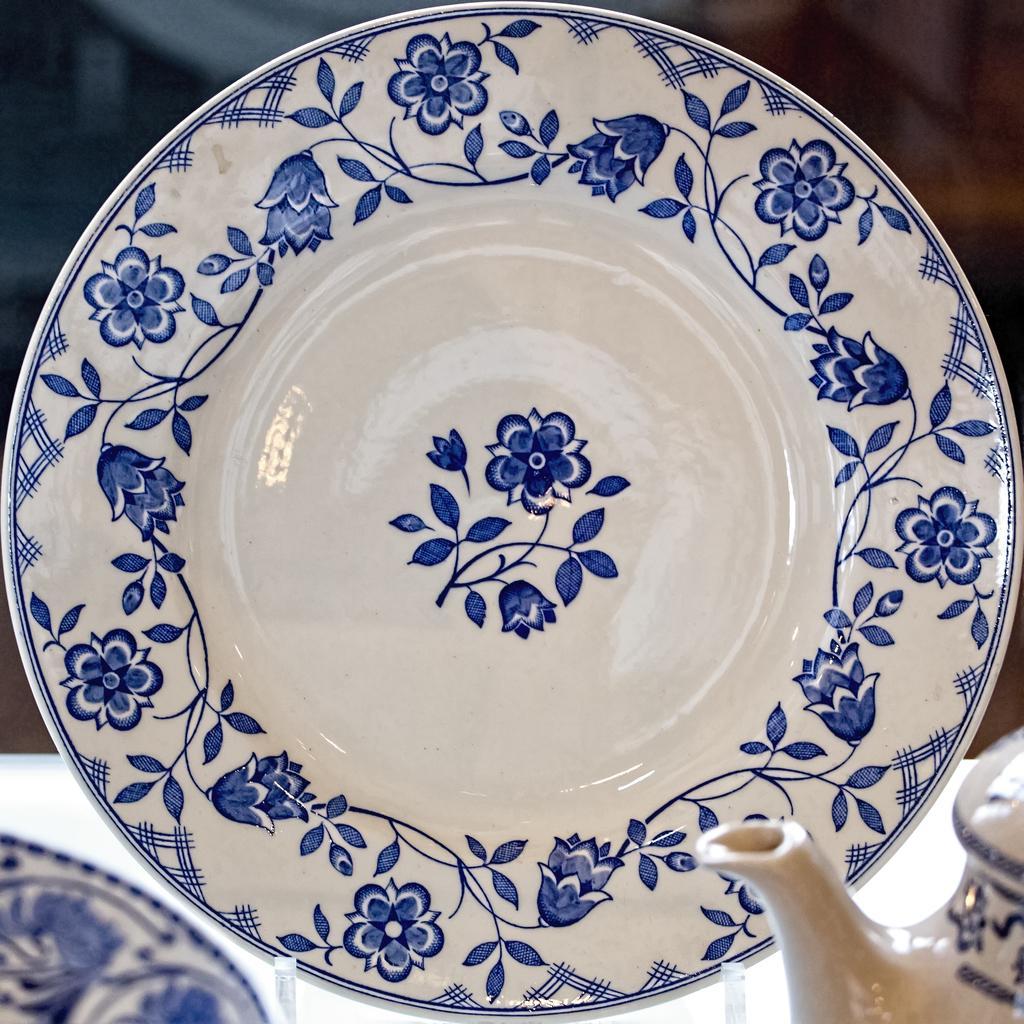How would you summarize this image in a sentence or two? In this image we can see a serving plate placed on the stand. In the foreground we can see a teapot. 